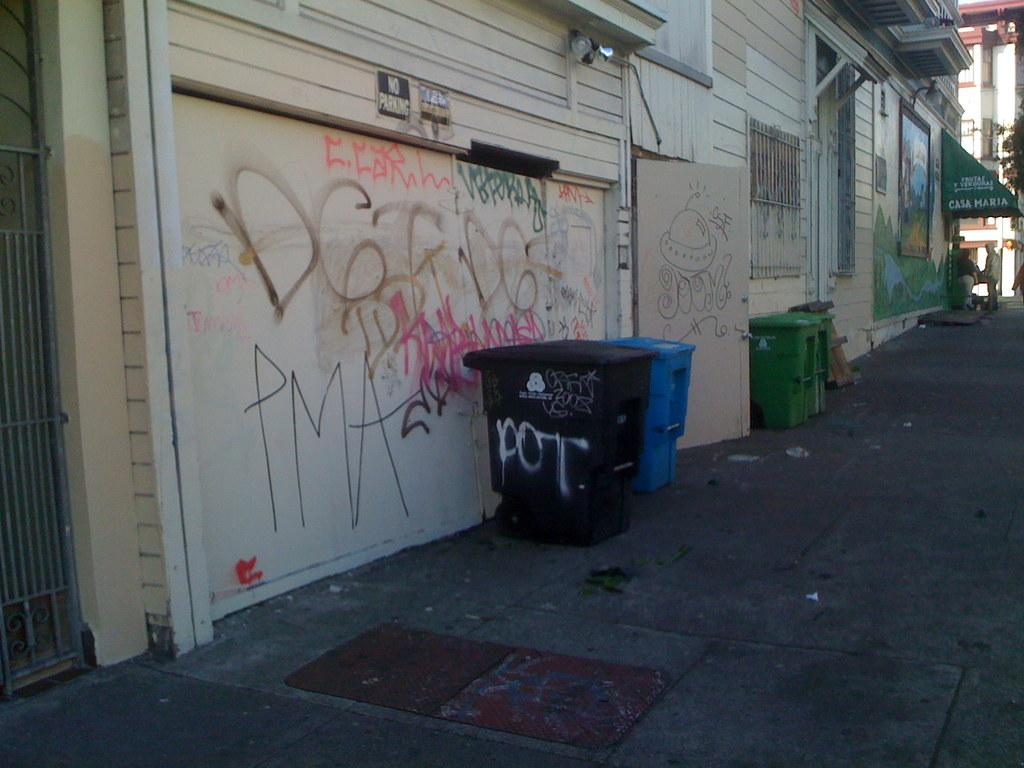<image>
Describe the image concisely. Black garbage can that says DOT next to a garage door. 